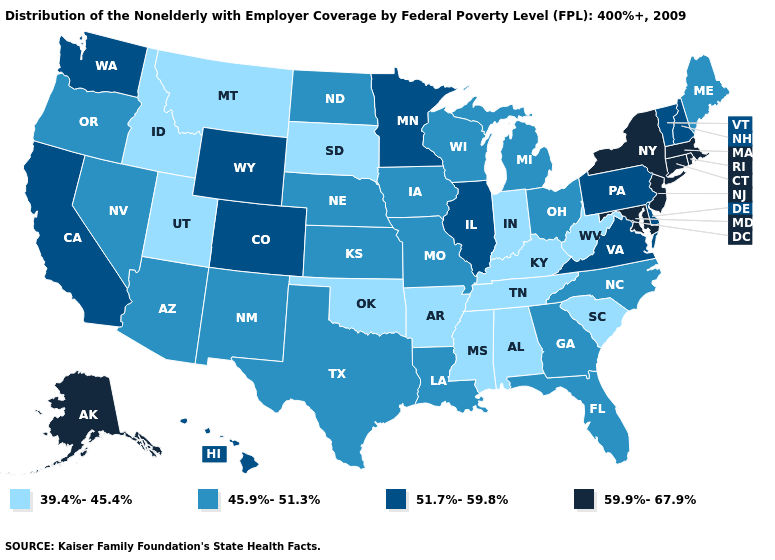Does Nevada have a higher value than Rhode Island?
Be succinct. No. Among the states that border Wisconsin , which have the highest value?
Answer briefly. Illinois, Minnesota. Name the states that have a value in the range 39.4%-45.4%?
Give a very brief answer. Alabama, Arkansas, Idaho, Indiana, Kentucky, Mississippi, Montana, Oklahoma, South Carolina, South Dakota, Tennessee, Utah, West Virginia. Does Washington have a lower value than Massachusetts?
Be succinct. Yes. What is the lowest value in the South?
Be succinct. 39.4%-45.4%. What is the value of Washington?
Short answer required. 51.7%-59.8%. Among the states that border Oregon , which have the highest value?
Short answer required. California, Washington. Among the states that border Tennessee , does North Carolina have the lowest value?
Write a very short answer. No. What is the value of Vermont?
Short answer required. 51.7%-59.8%. What is the value of Kentucky?
Write a very short answer. 39.4%-45.4%. Does Wyoming have the same value as California?
Write a very short answer. Yes. What is the value of Florida?
Quick response, please. 45.9%-51.3%. Does Wyoming have the highest value in the West?
Write a very short answer. No. Among the states that border Pennsylvania , does Ohio have the lowest value?
Concise answer only. No. Among the states that border Oklahoma , which have the lowest value?
Write a very short answer. Arkansas. 